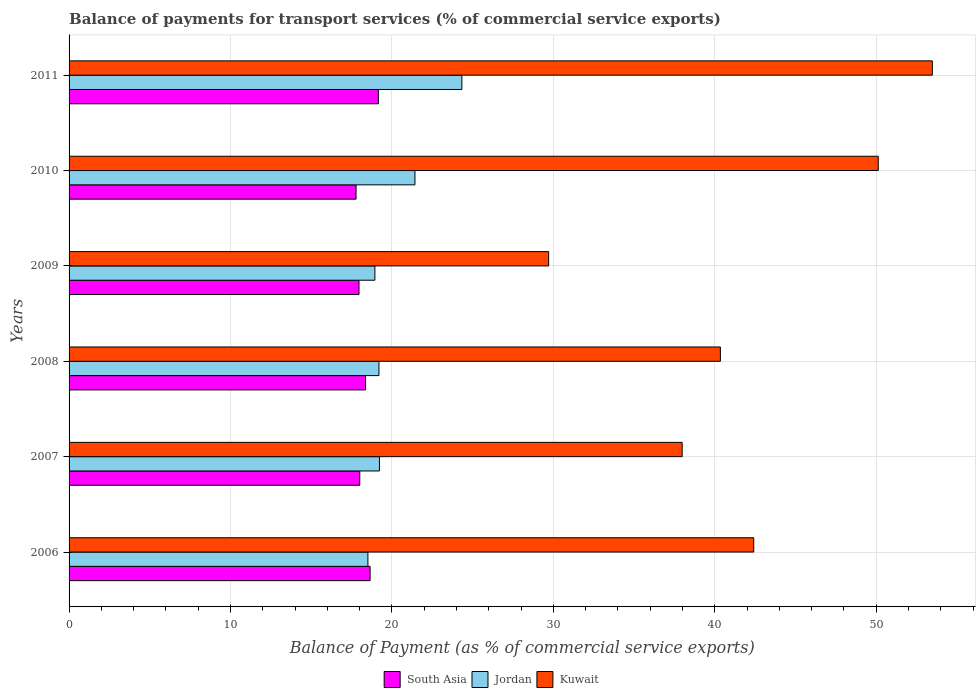Are the number of bars per tick equal to the number of legend labels?
Your response must be concise. Yes. Are the number of bars on each tick of the Y-axis equal?
Provide a short and direct response. Yes. How many bars are there on the 6th tick from the top?
Provide a succinct answer. 3. What is the label of the 1st group of bars from the top?
Make the answer very short. 2011. In how many cases, is the number of bars for a given year not equal to the number of legend labels?
Your answer should be very brief. 0. What is the balance of payments for transport services in Kuwait in 2010?
Ensure brevity in your answer.  50.13. Across all years, what is the maximum balance of payments for transport services in Jordan?
Your answer should be very brief. 24.33. Across all years, what is the minimum balance of payments for transport services in South Asia?
Your answer should be compact. 17.78. What is the total balance of payments for transport services in Kuwait in the graph?
Keep it short and to the point. 254.06. What is the difference between the balance of payments for transport services in South Asia in 2009 and that in 2011?
Make the answer very short. -1.2. What is the difference between the balance of payments for transport services in South Asia in 2009 and the balance of payments for transport services in Jordan in 2008?
Your answer should be very brief. -1.24. What is the average balance of payments for transport services in Jordan per year?
Offer a terse response. 20.27. In the year 2007, what is the difference between the balance of payments for transport services in Kuwait and balance of payments for transport services in South Asia?
Ensure brevity in your answer.  19.97. In how many years, is the balance of payments for transport services in South Asia greater than 10 %?
Keep it short and to the point. 6. What is the ratio of the balance of payments for transport services in South Asia in 2007 to that in 2010?
Make the answer very short. 1.01. Is the balance of payments for transport services in Jordan in 2006 less than that in 2011?
Your answer should be compact. Yes. What is the difference between the highest and the second highest balance of payments for transport services in Kuwait?
Give a very brief answer. 3.35. What is the difference between the highest and the lowest balance of payments for transport services in South Asia?
Offer a very short reply. 1.38. Is the sum of the balance of payments for transport services in South Asia in 2006 and 2011 greater than the maximum balance of payments for transport services in Kuwait across all years?
Provide a short and direct response. No. What does the 3rd bar from the top in 2010 represents?
Give a very brief answer. South Asia. Is it the case that in every year, the sum of the balance of payments for transport services in Kuwait and balance of payments for transport services in South Asia is greater than the balance of payments for transport services in Jordan?
Your response must be concise. Yes. How many bars are there?
Offer a very short reply. 18. Are all the bars in the graph horizontal?
Make the answer very short. Yes. How many years are there in the graph?
Your answer should be compact. 6. Does the graph contain grids?
Ensure brevity in your answer.  Yes. How are the legend labels stacked?
Give a very brief answer. Horizontal. What is the title of the graph?
Keep it short and to the point. Balance of payments for transport services (% of commercial service exports). What is the label or title of the X-axis?
Ensure brevity in your answer.  Balance of Payment (as % of commercial service exports). What is the Balance of Payment (as % of commercial service exports) of South Asia in 2006?
Make the answer very short. 18.65. What is the Balance of Payment (as % of commercial service exports) of Jordan in 2006?
Keep it short and to the point. 18.51. What is the Balance of Payment (as % of commercial service exports) of Kuwait in 2006?
Your answer should be compact. 42.41. What is the Balance of Payment (as % of commercial service exports) in South Asia in 2007?
Provide a succinct answer. 18.01. What is the Balance of Payment (as % of commercial service exports) in Jordan in 2007?
Provide a succinct answer. 19.23. What is the Balance of Payment (as % of commercial service exports) of Kuwait in 2007?
Give a very brief answer. 37.98. What is the Balance of Payment (as % of commercial service exports) in South Asia in 2008?
Your answer should be very brief. 18.37. What is the Balance of Payment (as % of commercial service exports) in Jordan in 2008?
Provide a short and direct response. 19.2. What is the Balance of Payment (as % of commercial service exports) of Kuwait in 2008?
Provide a short and direct response. 40.35. What is the Balance of Payment (as % of commercial service exports) of South Asia in 2009?
Make the answer very short. 17.96. What is the Balance of Payment (as % of commercial service exports) in Jordan in 2009?
Your answer should be compact. 18.95. What is the Balance of Payment (as % of commercial service exports) of Kuwait in 2009?
Your answer should be compact. 29.71. What is the Balance of Payment (as % of commercial service exports) of South Asia in 2010?
Make the answer very short. 17.78. What is the Balance of Payment (as % of commercial service exports) of Jordan in 2010?
Your answer should be compact. 21.43. What is the Balance of Payment (as % of commercial service exports) in Kuwait in 2010?
Keep it short and to the point. 50.13. What is the Balance of Payment (as % of commercial service exports) in South Asia in 2011?
Provide a succinct answer. 19.16. What is the Balance of Payment (as % of commercial service exports) of Jordan in 2011?
Provide a succinct answer. 24.33. What is the Balance of Payment (as % of commercial service exports) of Kuwait in 2011?
Your answer should be compact. 53.48. Across all years, what is the maximum Balance of Payment (as % of commercial service exports) of South Asia?
Provide a succinct answer. 19.16. Across all years, what is the maximum Balance of Payment (as % of commercial service exports) in Jordan?
Provide a succinct answer. 24.33. Across all years, what is the maximum Balance of Payment (as % of commercial service exports) of Kuwait?
Ensure brevity in your answer.  53.48. Across all years, what is the minimum Balance of Payment (as % of commercial service exports) in South Asia?
Offer a very short reply. 17.78. Across all years, what is the minimum Balance of Payment (as % of commercial service exports) in Jordan?
Keep it short and to the point. 18.51. Across all years, what is the minimum Balance of Payment (as % of commercial service exports) in Kuwait?
Offer a terse response. 29.71. What is the total Balance of Payment (as % of commercial service exports) in South Asia in the graph?
Make the answer very short. 109.93. What is the total Balance of Payment (as % of commercial service exports) in Jordan in the graph?
Ensure brevity in your answer.  121.64. What is the total Balance of Payment (as % of commercial service exports) of Kuwait in the graph?
Your answer should be very brief. 254.06. What is the difference between the Balance of Payment (as % of commercial service exports) in South Asia in 2006 and that in 2007?
Ensure brevity in your answer.  0.64. What is the difference between the Balance of Payment (as % of commercial service exports) of Jordan in 2006 and that in 2007?
Your answer should be compact. -0.71. What is the difference between the Balance of Payment (as % of commercial service exports) of Kuwait in 2006 and that in 2007?
Keep it short and to the point. 4.43. What is the difference between the Balance of Payment (as % of commercial service exports) in South Asia in 2006 and that in 2008?
Provide a short and direct response. 0.28. What is the difference between the Balance of Payment (as % of commercial service exports) in Jordan in 2006 and that in 2008?
Give a very brief answer. -0.68. What is the difference between the Balance of Payment (as % of commercial service exports) in Kuwait in 2006 and that in 2008?
Offer a terse response. 2.07. What is the difference between the Balance of Payment (as % of commercial service exports) in South Asia in 2006 and that in 2009?
Keep it short and to the point. 0.69. What is the difference between the Balance of Payment (as % of commercial service exports) of Jordan in 2006 and that in 2009?
Give a very brief answer. -0.43. What is the difference between the Balance of Payment (as % of commercial service exports) of Kuwait in 2006 and that in 2009?
Provide a short and direct response. 12.7. What is the difference between the Balance of Payment (as % of commercial service exports) of South Asia in 2006 and that in 2010?
Give a very brief answer. 0.87. What is the difference between the Balance of Payment (as % of commercial service exports) in Jordan in 2006 and that in 2010?
Your answer should be compact. -2.91. What is the difference between the Balance of Payment (as % of commercial service exports) of Kuwait in 2006 and that in 2010?
Offer a very short reply. -7.71. What is the difference between the Balance of Payment (as % of commercial service exports) of South Asia in 2006 and that in 2011?
Give a very brief answer. -0.52. What is the difference between the Balance of Payment (as % of commercial service exports) in Jordan in 2006 and that in 2011?
Offer a terse response. -5.82. What is the difference between the Balance of Payment (as % of commercial service exports) of Kuwait in 2006 and that in 2011?
Your response must be concise. -11.06. What is the difference between the Balance of Payment (as % of commercial service exports) in South Asia in 2007 and that in 2008?
Your response must be concise. -0.36. What is the difference between the Balance of Payment (as % of commercial service exports) of Jordan in 2007 and that in 2008?
Give a very brief answer. 0.03. What is the difference between the Balance of Payment (as % of commercial service exports) in Kuwait in 2007 and that in 2008?
Offer a terse response. -2.37. What is the difference between the Balance of Payment (as % of commercial service exports) in South Asia in 2007 and that in 2009?
Make the answer very short. 0.05. What is the difference between the Balance of Payment (as % of commercial service exports) of Jordan in 2007 and that in 2009?
Provide a short and direct response. 0.28. What is the difference between the Balance of Payment (as % of commercial service exports) of Kuwait in 2007 and that in 2009?
Give a very brief answer. 8.27. What is the difference between the Balance of Payment (as % of commercial service exports) of South Asia in 2007 and that in 2010?
Ensure brevity in your answer.  0.23. What is the difference between the Balance of Payment (as % of commercial service exports) in Kuwait in 2007 and that in 2010?
Ensure brevity in your answer.  -12.15. What is the difference between the Balance of Payment (as % of commercial service exports) of South Asia in 2007 and that in 2011?
Make the answer very short. -1.15. What is the difference between the Balance of Payment (as % of commercial service exports) of Jordan in 2007 and that in 2011?
Your answer should be very brief. -5.11. What is the difference between the Balance of Payment (as % of commercial service exports) of Kuwait in 2007 and that in 2011?
Keep it short and to the point. -15.5. What is the difference between the Balance of Payment (as % of commercial service exports) in South Asia in 2008 and that in 2009?
Your answer should be compact. 0.41. What is the difference between the Balance of Payment (as % of commercial service exports) in Jordan in 2008 and that in 2009?
Make the answer very short. 0.25. What is the difference between the Balance of Payment (as % of commercial service exports) of Kuwait in 2008 and that in 2009?
Make the answer very short. 10.64. What is the difference between the Balance of Payment (as % of commercial service exports) of South Asia in 2008 and that in 2010?
Your answer should be compact. 0.59. What is the difference between the Balance of Payment (as % of commercial service exports) in Jordan in 2008 and that in 2010?
Give a very brief answer. -2.23. What is the difference between the Balance of Payment (as % of commercial service exports) in Kuwait in 2008 and that in 2010?
Offer a terse response. -9.78. What is the difference between the Balance of Payment (as % of commercial service exports) of South Asia in 2008 and that in 2011?
Your answer should be compact. -0.8. What is the difference between the Balance of Payment (as % of commercial service exports) of Jordan in 2008 and that in 2011?
Offer a very short reply. -5.14. What is the difference between the Balance of Payment (as % of commercial service exports) in Kuwait in 2008 and that in 2011?
Give a very brief answer. -13.13. What is the difference between the Balance of Payment (as % of commercial service exports) of South Asia in 2009 and that in 2010?
Ensure brevity in your answer.  0.18. What is the difference between the Balance of Payment (as % of commercial service exports) of Jordan in 2009 and that in 2010?
Make the answer very short. -2.48. What is the difference between the Balance of Payment (as % of commercial service exports) in Kuwait in 2009 and that in 2010?
Provide a short and direct response. -20.42. What is the difference between the Balance of Payment (as % of commercial service exports) of South Asia in 2009 and that in 2011?
Make the answer very short. -1.2. What is the difference between the Balance of Payment (as % of commercial service exports) in Jordan in 2009 and that in 2011?
Keep it short and to the point. -5.39. What is the difference between the Balance of Payment (as % of commercial service exports) in Kuwait in 2009 and that in 2011?
Provide a succinct answer. -23.77. What is the difference between the Balance of Payment (as % of commercial service exports) of South Asia in 2010 and that in 2011?
Your answer should be compact. -1.38. What is the difference between the Balance of Payment (as % of commercial service exports) of Jordan in 2010 and that in 2011?
Offer a very short reply. -2.91. What is the difference between the Balance of Payment (as % of commercial service exports) of Kuwait in 2010 and that in 2011?
Keep it short and to the point. -3.35. What is the difference between the Balance of Payment (as % of commercial service exports) of South Asia in 2006 and the Balance of Payment (as % of commercial service exports) of Jordan in 2007?
Provide a short and direct response. -0.58. What is the difference between the Balance of Payment (as % of commercial service exports) of South Asia in 2006 and the Balance of Payment (as % of commercial service exports) of Kuwait in 2007?
Your response must be concise. -19.33. What is the difference between the Balance of Payment (as % of commercial service exports) in Jordan in 2006 and the Balance of Payment (as % of commercial service exports) in Kuwait in 2007?
Your answer should be very brief. -19.47. What is the difference between the Balance of Payment (as % of commercial service exports) in South Asia in 2006 and the Balance of Payment (as % of commercial service exports) in Jordan in 2008?
Offer a very short reply. -0.55. What is the difference between the Balance of Payment (as % of commercial service exports) in South Asia in 2006 and the Balance of Payment (as % of commercial service exports) in Kuwait in 2008?
Your answer should be compact. -21.7. What is the difference between the Balance of Payment (as % of commercial service exports) of Jordan in 2006 and the Balance of Payment (as % of commercial service exports) of Kuwait in 2008?
Provide a short and direct response. -21.84. What is the difference between the Balance of Payment (as % of commercial service exports) in South Asia in 2006 and the Balance of Payment (as % of commercial service exports) in Jordan in 2009?
Make the answer very short. -0.3. What is the difference between the Balance of Payment (as % of commercial service exports) of South Asia in 2006 and the Balance of Payment (as % of commercial service exports) of Kuwait in 2009?
Give a very brief answer. -11.06. What is the difference between the Balance of Payment (as % of commercial service exports) of Jordan in 2006 and the Balance of Payment (as % of commercial service exports) of Kuwait in 2009?
Offer a terse response. -11.2. What is the difference between the Balance of Payment (as % of commercial service exports) in South Asia in 2006 and the Balance of Payment (as % of commercial service exports) in Jordan in 2010?
Keep it short and to the point. -2.78. What is the difference between the Balance of Payment (as % of commercial service exports) in South Asia in 2006 and the Balance of Payment (as % of commercial service exports) in Kuwait in 2010?
Make the answer very short. -31.48. What is the difference between the Balance of Payment (as % of commercial service exports) in Jordan in 2006 and the Balance of Payment (as % of commercial service exports) in Kuwait in 2010?
Your answer should be compact. -31.62. What is the difference between the Balance of Payment (as % of commercial service exports) in South Asia in 2006 and the Balance of Payment (as % of commercial service exports) in Jordan in 2011?
Provide a succinct answer. -5.68. What is the difference between the Balance of Payment (as % of commercial service exports) of South Asia in 2006 and the Balance of Payment (as % of commercial service exports) of Kuwait in 2011?
Offer a terse response. -34.83. What is the difference between the Balance of Payment (as % of commercial service exports) of Jordan in 2006 and the Balance of Payment (as % of commercial service exports) of Kuwait in 2011?
Make the answer very short. -34.97. What is the difference between the Balance of Payment (as % of commercial service exports) in South Asia in 2007 and the Balance of Payment (as % of commercial service exports) in Jordan in 2008?
Your response must be concise. -1.19. What is the difference between the Balance of Payment (as % of commercial service exports) in South Asia in 2007 and the Balance of Payment (as % of commercial service exports) in Kuwait in 2008?
Give a very brief answer. -22.34. What is the difference between the Balance of Payment (as % of commercial service exports) in Jordan in 2007 and the Balance of Payment (as % of commercial service exports) in Kuwait in 2008?
Provide a short and direct response. -21.12. What is the difference between the Balance of Payment (as % of commercial service exports) in South Asia in 2007 and the Balance of Payment (as % of commercial service exports) in Jordan in 2009?
Offer a very short reply. -0.94. What is the difference between the Balance of Payment (as % of commercial service exports) in South Asia in 2007 and the Balance of Payment (as % of commercial service exports) in Kuwait in 2009?
Provide a succinct answer. -11.7. What is the difference between the Balance of Payment (as % of commercial service exports) of Jordan in 2007 and the Balance of Payment (as % of commercial service exports) of Kuwait in 2009?
Your answer should be very brief. -10.48. What is the difference between the Balance of Payment (as % of commercial service exports) of South Asia in 2007 and the Balance of Payment (as % of commercial service exports) of Jordan in 2010?
Keep it short and to the point. -3.42. What is the difference between the Balance of Payment (as % of commercial service exports) in South Asia in 2007 and the Balance of Payment (as % of commercial service exports) in Kuwait in 2010?
Offer a terse response. -32.12. What is the difference between the Balance of Payment (as % of commercial service exports) in Jordan in 2007 and the Balance of Payment (as % of commercial service exports) in Kuwait in 2010?
Offer a very short reply. -30.9. What is the difference between the Balance of Payment (as % of commercial service exports) in South Asia in 2007 and the Balance of Payment (as % of commercial service exports) in Jordan in 2011?
Ensure brevity in your answer.  -6.32. What is the difference between the Balance of Payment (as % of commercial service exports) in South Asia in 2007 and the Balance of Payment (as % of commercial service exports) in Kuwait in 2011?
Ensure brevity in your answer.  -35.47. What is the difference between the Balance of Payment (as % of commercial service exports) of Jordan in 2007 and the Balance of Payment (as % of commercial service exports) of Kuwait in 2011?
Your answer should be compact. -34.25. What is the difference between the Balance of Payment (as % of commercial service exports) in South Asia in 2008 and the Balance of Payment (as % of commercial service exports) in Jordan in 2009?
Ensure brevity in your answer.  -0.58. What is the difference between the Balance of Payment (as % of commercial service exports) in South Asia in 2008 and the Balance of Payment (as % of commercial service exports) in Kuwait in 2009?
Give a very brief answer. -11.34. What is the difference between the Balance of Payment (as % of commercial service exports) in Jordan in 2008 and the Balance of Payment (as % of commercial service exports) in Kuwait in 2009?
Provide a short and direct response. -10.51. What is the difference between the Balance of Payment (as % of commercial service exports) in South Asia in 2008 and the Balance of Payment (as % of commercial service exports) in Jordan in 2010?
Your answer should be very brief. -3.06. What is the difference between the Balance of Payment (as % of commercial service exports) in South Asia in 2008 and the Balance of Payment (as % of commercial service exports) in Kuwait in 2010?
Provide a short and direct response. -31.76. What is the difference between the Balance of Payment (as % of commercial service exports) in Jordan in 2008 and the Balance of Payment (as % of commercial service exports) in Kuwait in 2010?
Keep it short and to the point. -30.93. What is the difference between the Balance of Payment (as % of commercial service exports) of South Asia in 2008 and the Balance of Payment (as % of commercial service exports) of Jordan in 2011?
Your response must be concise. -5.97. What is the difference between the Balance of Payment (as % of commercial service exports) in South Asia in 2008 and the Balance of Payment (as % of commercial service exports) in Kuwait in 2011?
Give a very brief answer. -35.11. What is the difference between the Balance of Payment (as % of commercial service exports) in Jordan in 2008 and the Balance of Payment (as % of commercial service exports) in Kuwait in 2011?
Your answer should be very brief. -34.28. What is the difference between the Balance of Payment (as % of commercial service exports) of South Asia in 2009 and the Balance of Payment (as % of commercial service exports) of Jordan in 2010?
Your answer should be very brief. -3.47. What is the difference between the Balance of Payment (as % of commercial service exports) of South Asia in 2009 and the Balance of Payment (as % of commercial service exports) of Kuwait in 2010?
Your answer should be compact. -32.17. What is the difference between the Balance of Payment (as % of commercial service exports) in Jordan in 2009 and the Balance of Payment (as % of commercial service exports) in Kuwait in 2010?
Make the answer very short. -31.18. What is the difference between the Balance of Payment (as % of commercial service exports) of South Asia in 2009 and the Balance of Payment (as % of commercial service exports) of Jordan in 2011?
Give a very brief answer. -6.37. What is the difference between the Balance of Payment (as % of commercial service exports) of South Asia in 2009 and the Balance of Payment (as % of commercial service exports) of Kuwait in 2011?
Your response must be concise. -35.52. What is the difference between the Balance of Payment (as % of commercial service exports) of Jordan in 2009 and the Balance of Payment (as % of commercial service exports) of Kuwait in 2011?
Ensure brevity in your answer.  -34.53. What is the difference between the Balance of Payment (as % of commercial service exports) of South Asia in 2010 and the Balance of Payment (as % of commercial service exports) of Jordan in 2011?
Provide a short and direct response. -6.55. What is the difference between the Balance of Payment (as % of commercial service exports) in South Asia in 2010 and the Balance of Payment (as % of commercial service exports) in Kuwait in 2011?
Your answer should be compact. -35.7. What is the difference between the Balance of Payment (as % of commercial service exports) in Jordan in 2010 and the Balance of Payment (as % of commercial service exports) in Kuwait in 2011?
Make the answer very short. -32.05. What is the average Balance of Payment (as % of commercial service exports) in South Asia per year?
Provide a succinct answer. 18.32. What is the average Balance of Payment (as % of commercial service exports) of Jordan per year?
Your response must be concise. 20.27. What is the average Balance of Payment (as % of commercial service exports) in Kuwait per year?
Provide a short and direct response. 42.34. In the year 2006, what is the difference between the Balance of Payment (as % of commercial service exports) of South Asia and Balance of Payment (as % of commercial service exports) of Jordan?
Ensure brevity in your answer.  0.14. In the year 2006, what is the difference between the Balance of Payment (as % of commercial service exports) in South Asia and Balance of Payment (as % of commercial service exports) in Kuwait?
Your answer should be very brief. -23.77. In the year 2006, what is the difference between the Balance of Payment (as % of commercial service exports) in Jordan and Balance of Payment (as % of commercial service exports) in Kuwait?
Your response must be concise. -23.9. In the year 2007, what is the difference between the Balance of Payment (as % of commercial service exports) in South Asia and Balance of Payment (as % of commercial service exports) in Jordan?
Your answer should be very brief. -1.22. In the year 2007, what is the difference between the Balance of Payment (as % of commercial service exports) in South Asia and Balance of Payment (as % of commercial service exports) in Kuwait?
Your answer should be compact. -19.97. In the year 2007, what is the difference between the Balance of Payment (as % of commercial service exports) in Jordan and Balance of Payment (as % of commercial service exports) in Kuwait?
Offer a terse response. -18.75. In the year 2008, what is the difference between the Balance of Payment (as % of commercial service exports) in South Asia and Balance of Payment (as % of commercial service exports) in Jordan?
Make the answer very short. -0.83. In the year 2008, what is the difference between the Balance of Payment (as % of commercial service exports) of South Asia and Balance of Payment (as % of commercial service exports) of Kuwait?
Ensure brevity in your answer.  -21.98. In the year 2008, what is the difference between the Balance of Payment (as % of commercial service exports) of Jordan and Balance of Payment (as % of commercial service exports) of Kuwait?
Keep it short and to the point. -21.15. In the year 2009, what is the difference between the Balance of Payment (as % of commercial service exports) of South Asia and Balance of Payment (as % of commercial service exports) of Jordan?
Offer a terse response. -0.98. In the year 2009, what is the difference between the Balance of Payment (as % of commercial service exports) of South Asia and Balance of Payment (as % of commercial service exports) of Kuwait?
Provide a short and direct response. -11.75. In the year 2009, what is the difference between the Balance of Payment (as % of commercial service exports) of Jordan and Balance of Payment (as % of commercial service exports) of Kuwait?
Keep it short and to the point. -10.76. In the year 2010, what is the difference between the Balance of Payment (as % of commercial service exports) of South Asia and Balance of Payment (as % of commercial service exports) of Jordan?
Ensure brevity in your answer.  -3.65. In the year 2010, what is the difference between the Balance of Payment (as % of commercial service exports) of South Asia and Balance of Payment (as % of commercial service exports) of Kuwait?
Your response must be concise. -32.35. In the year 2010, what is the difference between the Balance of Payment (as % of commercial service exports) of Jordan and Balance of Payment (as % of commercial service exports) of Kuwait?
Offer a very short reply. -28.7. In the year 2011, what is the difference between the Balance of Payment (as % of commercial service exports) in South Asia and Balance of Payment (as % of commercial service exports) in Jordan?
Your answer should be compact. -5.17. In the year 2011, what is the difference between the Balance of Payment (as % of commercial service exports) in South Asia and Balance of Payment (as % of commercial service exports) in Kuwait?
Offer a very short reply. -34.31. In the year 2011, what is the difference between the Balance of Payment (as % of commercial service exports) in Jordan and Balance of Payment (as % of commercial service exports) in Kuwait?
Make the answer very short. -29.15. What is the ratio of the Balance of Payment (as % of commercial service exports) of South Asia in 2006 to that in 2007?
Your answer should be compact. 1.04. What is the ratio of the Balance of Payment (as % of commercial service exports) in Jordan in 2006 to that in 2007?
Ensure brevity in your answer.  0.96. What is the ratio of the Balance of Payment (as % of commercial service exports) in Kuwait in 2006 to that in 2007?
Provide a short and direct response. 1.12. What is the ratio of the Balance of Payment (as % of commercial service exports) of South Asia in 2006 to that in 2008?
Make the answer very short. 1.02. What is the ratio of the Balance of Payment (as % of commercial service exports) in Jordan in 2006 to that in 2008?
Provide a short and direct response. 0.96. What is the ratio of the Balance of Payment (as % of commercial service exports) of Kuwait in 2006 to that in 2008?
Give a very brief answer. 1.05. What is the ratio of the Balance of Payment (as % of commercial service exports) in South Asia in 2006 to that in 2009?
Offer a terse response. 1.04. What is the ratio of the Balance of Payment (as % of commercial service exports) in Jordan in 2006 to that in 2009?
Your answer should be compact. 0.98. What is the ratio of the Balance of Payment (as % of commercial service exports) in Kuwait in 2006 to that in 2009?
Offer a very short reply. 1.43. What is the ratio of the Balance of Payment (as % of commercial service exports) in South Asia in 2006 to that in 2010?
Make the answer very short. 1.05. What is the ratio of the Balance of Payment (as % of commercial service exports) of Jordan in 2006 to that in 2010?
Make the answer very short. 0.86. What is the ratio of the Balance of Payment (as % of commercial service exports) of Kuwait in 2006 to that in 2010?
Provide a succinct answer. 0.85. What is the ratio of the Balance of Payment (as % of commercial service exports) in South Asia in 2006 to that in 2011?
Provide a succinct answer. 0.97. What is the ratio of the Balance of Payment (as % of commercial service exports) in Jordan in 2006 to that in 2011?
Your response must be concise. 0.76. What is the ratio of the Balance of Payment (as % of commercial service exports) of Kuwait in 2006 to that in 2011?
Your answer should be very brief. 0.79. What is the ratio of the Balance of Payment (as % of commercial service exports) of South Asia in 2007 to that in 2008?
Make the answer very short. 0.98. What is the ratio of the Balance of Payment (as % of commercial service exports) of Kuwait in 2007 to that in 2008?
Provide a succinct answer. 0.94. What is the ratio of the Balance of Payment (as % of commercial service exports) in South Asia in 2007 to that in 2009?
Make the answer very short. 1. What is the ratio of the Balance of Payment (as % of commercial service exports) in Jordan in 2007 to that in 2009?
Provide a short and direct response. 1.01. What is the ratio of the Balance of Payment (as % of commercial service exports) of Kuwait in 2007 to that in 2009?
Make the answer very short. 1.28. What is the ratio of the Balance of Payment (as % of commercial service exports) in South Asia in 2007 to that in 2010?
Ensure brevity in your answer.  1.01. What is the ratio of the Balance of Payment (as % of commercial service exports) in Jordan in 2007 to that in 2010?
Your answer should be very brief. 0.9. What is the ratio of the Balance of Payment (as % of commercial service exports) of Kuwait in 2007 to that in 2010?
Make the answer very short. 0.76. What is the ratio of the Balance of Payment (as % of commercial service exports) of South Asia in 2007 to that in 2011?
Provide a short and direct response. 0.94. What is the ratio of the Balance of Payment (as % of commercial service exports) of Jordan in 2007 to that in 2011?
Provide a short and direct response. 0.79. What is the ratio of the Balance of Payment (as % of commercial service exports) of Kuwait in 2007 to that in 2011?
Provide a succinct answer. 0.71. What is the ratio of the Balance of Payment (as % of commercial service exports) of South Asia in 2008 to that in 2009?
Your answer should be very brief. 1.02. What is the ratio of the Balance of Payment (as % of commercial service exports) of Jordan in 2008 to that in 2009?
Offer a very short reply. 1.01. What is the ratio of the Balance of Payment (as % of commercial service exports) in Kuwait in 2008 to that in 2009?
Give a very brief answer. 1.36. What is the ratio of the Balance of Payment (as % of commercial service exports) of South Asia in 2008 to that in 2010?
Make the answer very short. 1.03. What is the ratio of the Balance of Payment (as % of commercial service exports) of Jordan in 2008 to that in 2010?
Offer a terse response. 0.9. What is the ratio of the Balance of Payment (as % of commercial service exports) of Kuwait in 2008 to that in 2010?
Your answer should be very brief. 0.8. What is the ratio of the Balance of Payment (as % of commercial service exports) in South Asia in 2008 to that in 2011?
Offer a very short reply. 0.96. What is the ratio of the Balance of Payment (as % of commercial service exports) of Jordan in 2008 to that in 2011?
Offer a very short reply. 0.79. What is the ratio of the Balance of Payment (as % of commercial service exports) in Kuwait in 2008 to that in 2011?
Make the answer very short. 0.75. What is the ratio of the Balance of Payment (as % of commercial service exports) of South Asia in 2009 to that in 2010?
Offer a very short reply. 1.01. What is the ratio of the Balance of Payment (as % of commercial service exports) of Jordan in 2009 to that in 2010?
Your answer should be very brief. 0.88. What is the ratio of the Balance of Payment (as % of commercial service exports) in Kuwait in 2009 to that in 2010?
Offer a terse response. 0.59. What is the ratio of the Balance of Payment (as % of commercial service exports) in South Asia in 2009 to that in 2011?
Your answer should be very brief. 0.94. What is the ratio of the Balance of Payment (as % of commercial service exports) in Jordan in 2009 to that in 2011?
Offer a terse response. 0.78. What is the ratio of the Balance of Payment (as % of commercial service exports) of Kuwait in 2009 to that in 2011?
Provide a succinct answer. 0.56. What is the ratio of the Balance of Payment (as % of commercial service exports) in South Asia in 2010 to that in 2011?
Offer a terse response. 0.93. What is the ratio of the Balance of Payment (as % of commercial service exports) of Jordan in 2010 to that in 2011?
Provide a succinct answer. 0.88. What is the ratio of the Balance of Payment (as % of commercial service exports) in Kuwait in 2010 to that in 2011?
Make the answer very short. 0.94. What is the difference between the highest and the second highest Balance of Payment (as % of commercial service exports) of South Asia?
Give a very brief answer. 0.52. What is the difference between the highest and the second highest Balance of Payment (as % of commercial service exports) of Jordan?
Your response must be concise. 2.91. What is the difference between the highest and the second highest Balance of Payment (as % of commercial service exports) in Kuwait?
Offer a very short reply. 3.35. What is the difference between the highest and the lowest Balance of Payment (as % of commercial service exports) of South Asia?
Offer a terse response. 1.38. What is the difference between the highest and the lowest Balance of Payment (as % of commercial service exports) of Jordan?
Ensure brevity in your answer.  5.82. What is the difference between the highest and the lowest Balance of Payment (as % of commercial service exports) in Kuwait?
Keep it short and to the point. 23.77. 